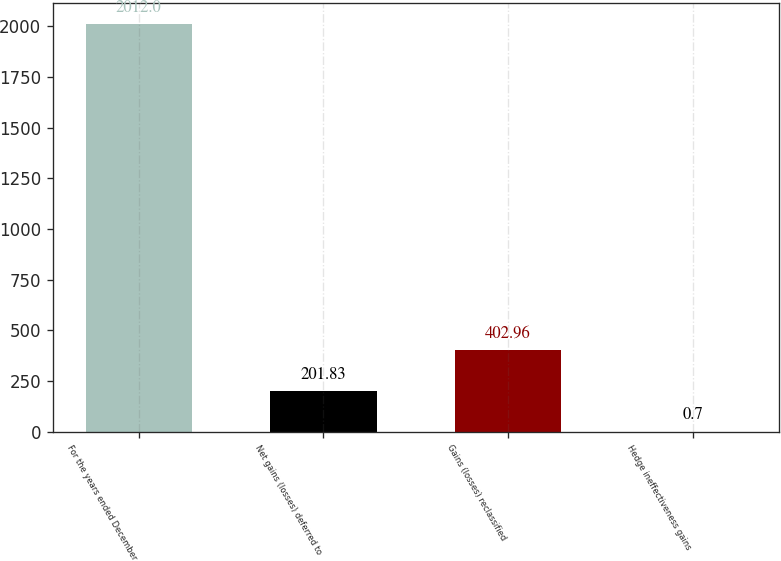Convert chart. <chart><loc_0><loc_0><loc_500><loc_500><bar_chart><fcel>For the years ended December<fcel>Net gains (losses) deferred to<fcel>Gains (losses) reclassified<fcel>Hedge ineffectiveness gains<nl><fcel>2012<fcel>201.83<fcel>402.96<fcel>0.7<nl></chart> 